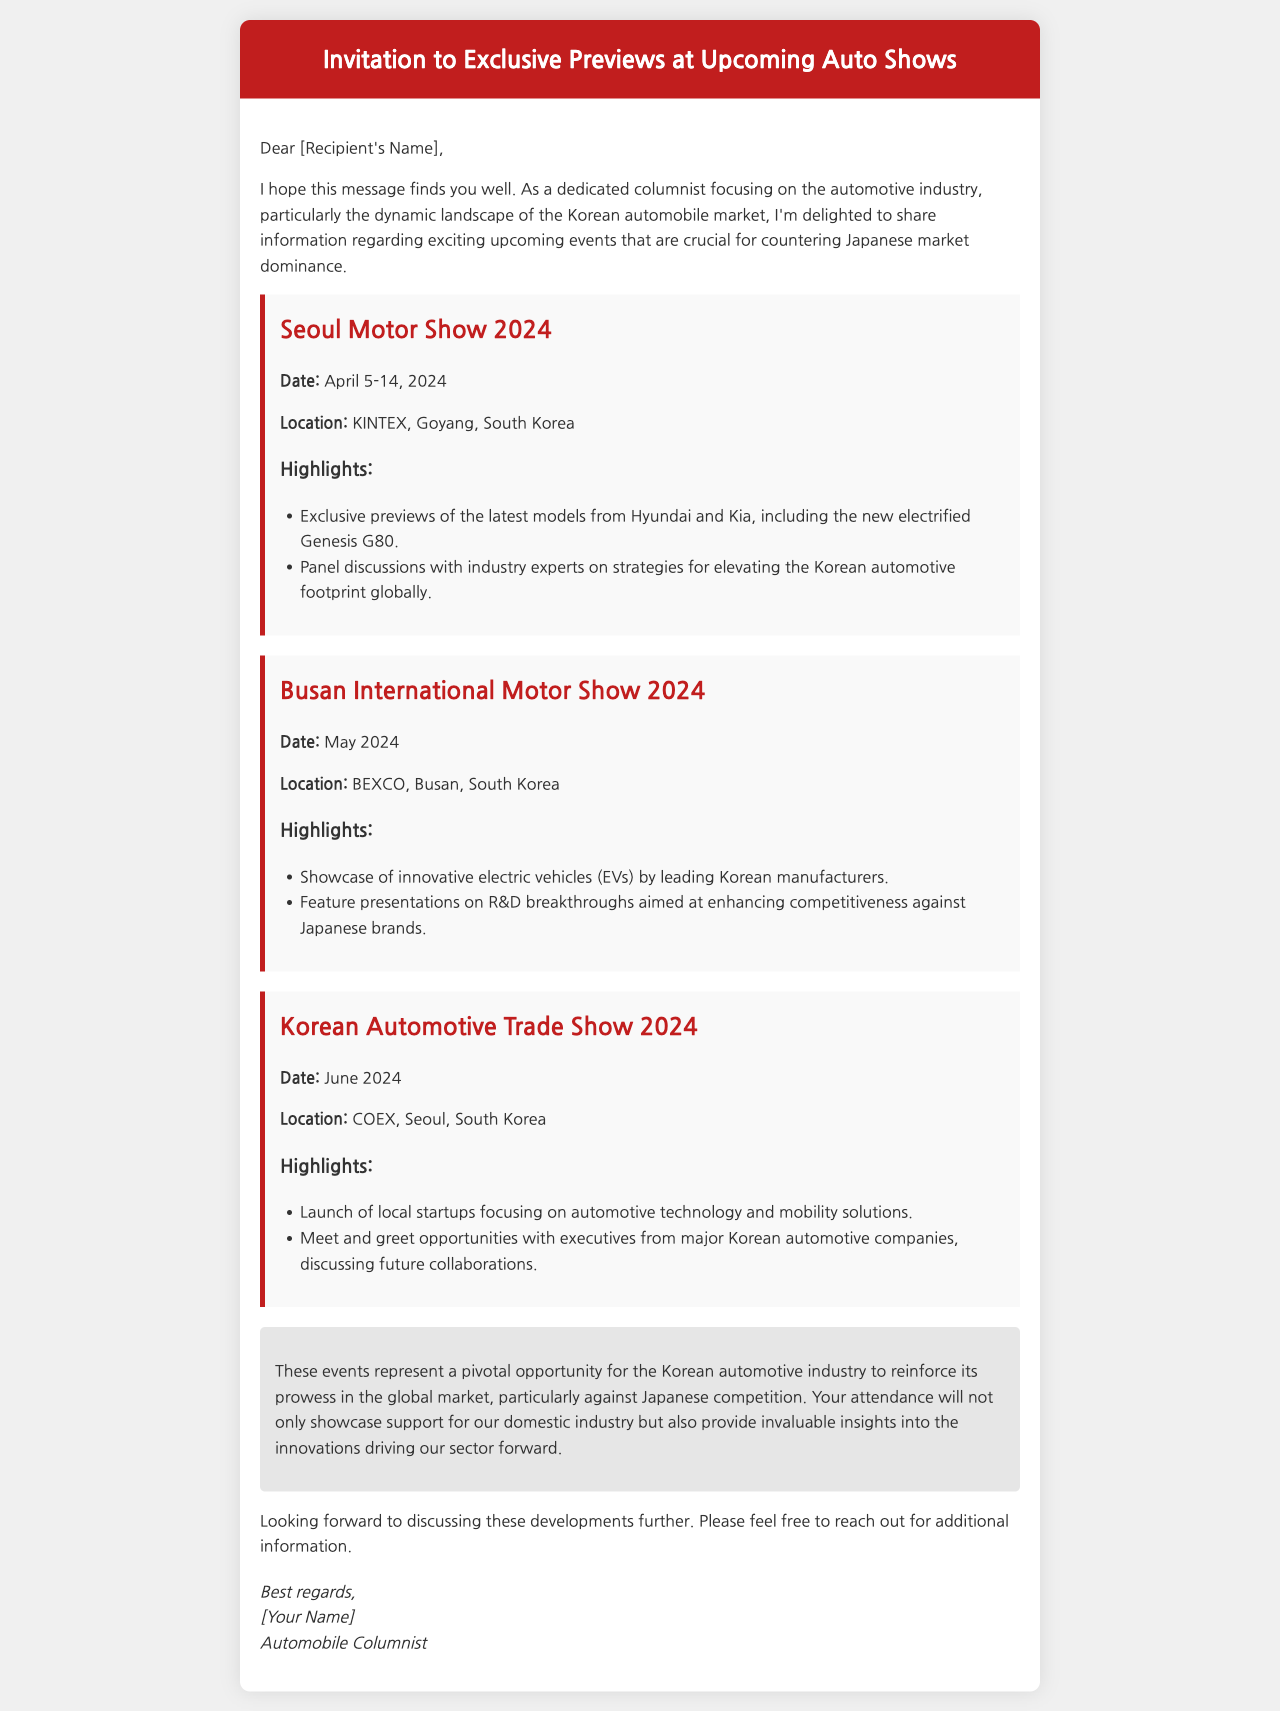What is the date of the Seoul Motor Show 2024? The date is clearly specified in the document under the Seoul Motor Show section as April 5-14, 2024.
Answer: April 5-14, 2024 Where is the Busan International Motor Show 2024 located? The location is listed in the event details, which states BEXCO, Busan, South Korea.
Answer: BEXCO, Busan, South Korea What vehicle is mentioned as part of Hyundai's preview? The document highlights the new electrified Genesis G80 in the Seoul Motor Show section.
Answer: new electrified Genesis G80 Which event showcases innovative electric vehicles? The document specifies that the Busan International Motor Show 2024 will showcase innovative electric vehicles.
Answer: Busan International Motor Show 2024 What is the primary purpose of the Korean Automotive Trade Show 2024? The purpose is described in the document as the launch of local startups focusing on automotive technology and mobility solutions.
Answer: Launch of local startups What color is the header of the email? The color is described as #c11e1e in the styling section, which refers to the bright red header.
Answer: #c11e1e What type of discussions will take place at the Seoul Motor Show? The document mentions panel discussions with industry experts on strategies for the Korean automotive market.
Answer: Panel discussions What opportunity is highlighted for attendees of these events? The document emphasizes how attendance will showcase support for the domestic industry and provide insights into innovations.
Answer: Support for domestic industry What will attendees have a chance to do at the Korean Automotive Trade Show 2024? The document states that there will be meet and greet opportunities with executives from major Korean automotive companies.
Answer: Meet and greet opportunities 